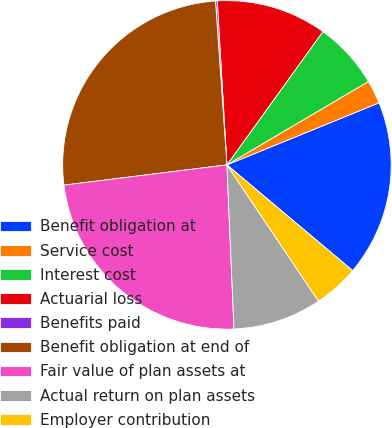<chart> <loc_0><loc_0><loc_500><loc_500><pie_chart><fcel>Benefit obligation at<fcel>Service cost<fcel>Interest cost<fcel>Actuarial loss<fcel>Benefits paid<fcel>Benefit obligation at end of<fcel>Fair value of plan assets at<fcel>Actual return on plan assets<fcel>Employer contribution<nl><fcel>17.29%<fcel>2.31%<fcel>6.59%<fcel>10.87%<fcel>0.17%<fcel>25.85%<fcel>23.71%<fcel>8.73%<fcel>4.45%<nl></chart> 